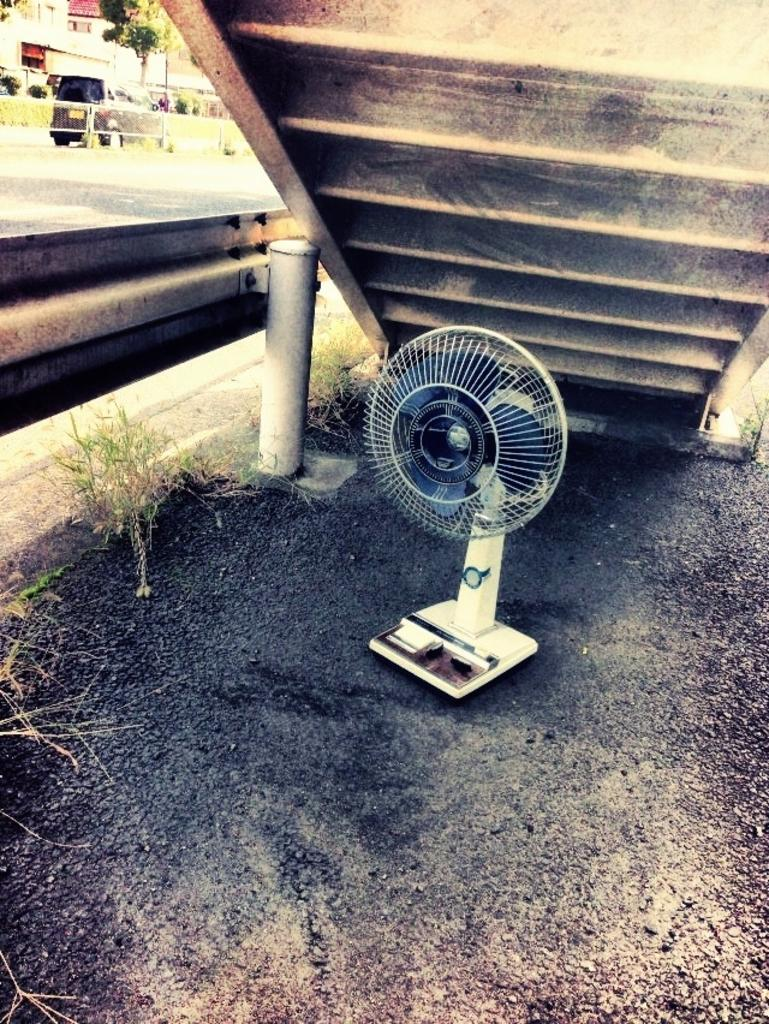What object can be seen on the surface in the image? There is a fan on the surface in the image. What architectural feature is located above the fan? There are steps above the fan. What type of natural environment is visible in the image? There is grass visible in the image. What structures can be seen in the background? There is a pole, a road, a vehicle, a fence, a tree, plants, and a wall in the background. What type of verse can be heard recited by the frogs in the image? There are no frogs present in the image, and therefore no recitation of verses can be heard. What sense is being stimulated by the objects in the image? The image primarily stimulates the sense of sight, as it is a visual representation of various objects and structures. 